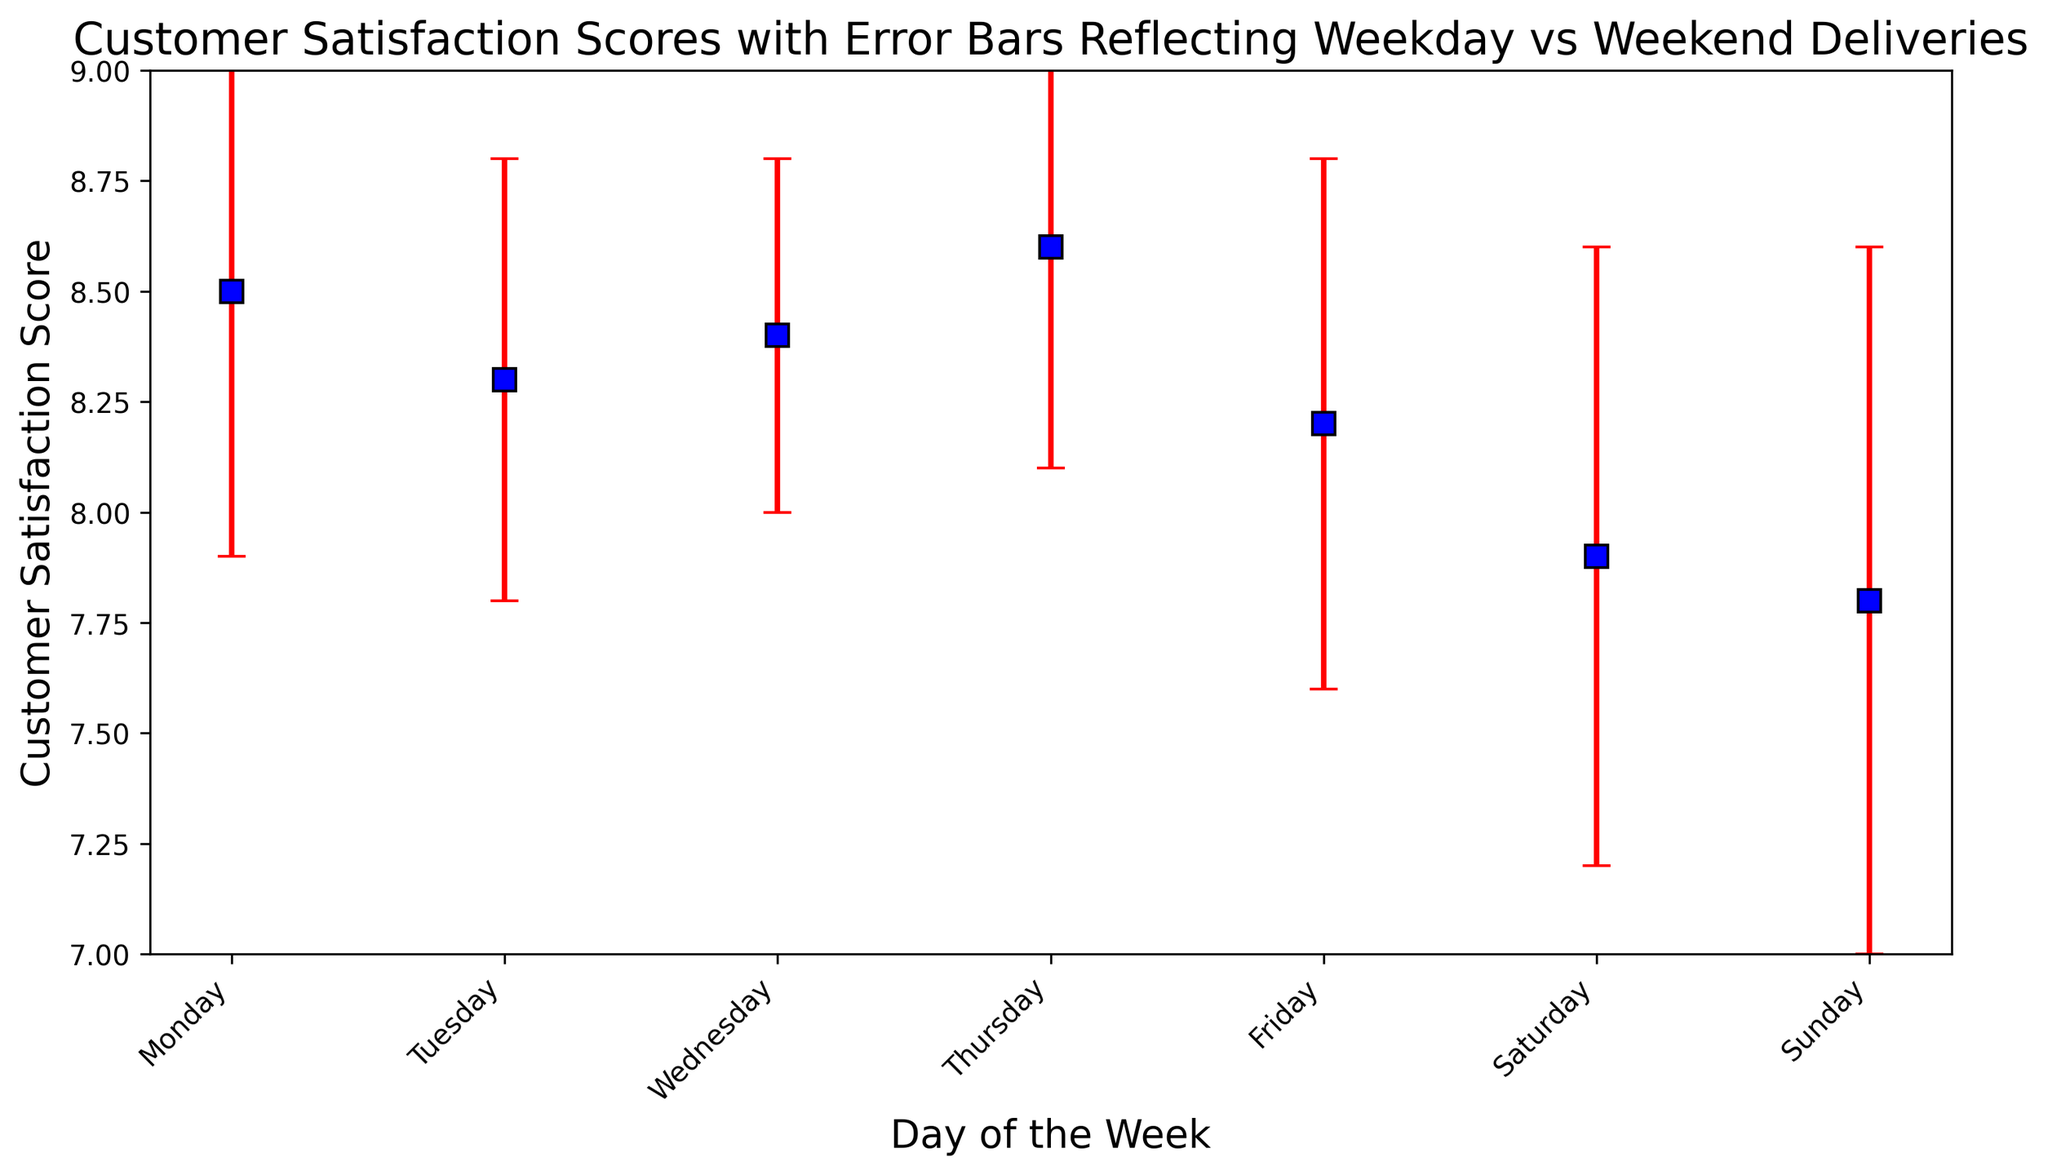Which day has the highest customer satisfaction score? The figure shows that Thursday has the highest mean customer satisfaction score of 8.6.
Answer: Thursday Compare the customer satisfaction scores for Saturday and Sunday. Which day has a lower score? Saturday has a mean score of 7.9, whereas Sunday has a mean score of 7.8. Hence, Sunday has a slightly lower score than Saturday.
Answer: Sunday What is the difference in customer satisfaction scores between Monday and Friday? Monday has a mean score of 8.5, and Friday has a mean score of 8.2. The difference is calculated as 8.5 - 8.2 = 0.3.
Answer: 0.3 Which day has the largest error bar, indicating the most variability in customer satisfaction? The figure shows that Sunday has the largest error bar, suggesting the most variability (standard error of 0.8).
Answer: Sunday What is the average customer satisfaction score for the weekdays only (Monday to Friday)? Add the scores and divide by the number of weekdays: (8.5 + 8.3 + 8.4 + 8.6 + 8.2) / 5 = 42.0 / 5 = 8.4.
Answer: 8.4 Looking at the error bars, which day has the smallest standard error? Wednesday has the smallest error bar, indicating the least standard error (0.4).
Answer: Wednesday What is the range of customer satisfaction scores for the entire week? The highest score is 8.6 (Thursday) and the lowest is 7.8 (Sunday). The range is 8.6 - 7.8 = 0.8.
Answer: 0.8 Between which two consecutive days is there the largest drop in the customer satisfaction score? The largest drop occurs between Thursday (8.6) and Friday (8.2), which is a difference of 0.4.
Answer: Thursday and Friday 